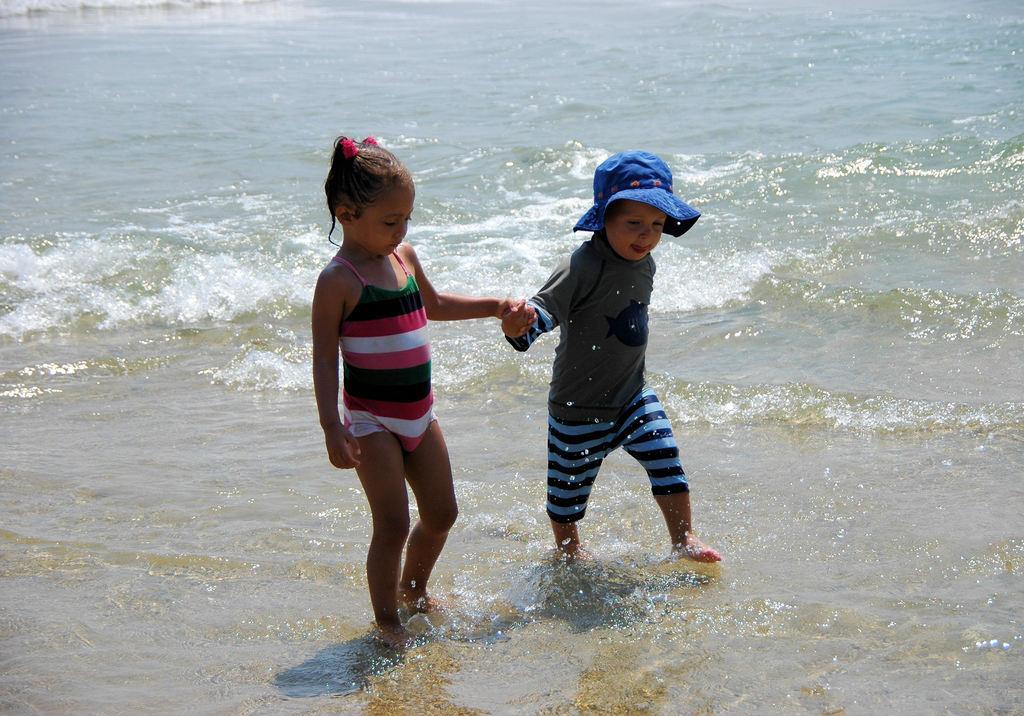Please provide a concise description of this image. In this picture I can observe two children walking in the water. One of them is wearing a blue color hat on his head. In the background there is an ocean. 